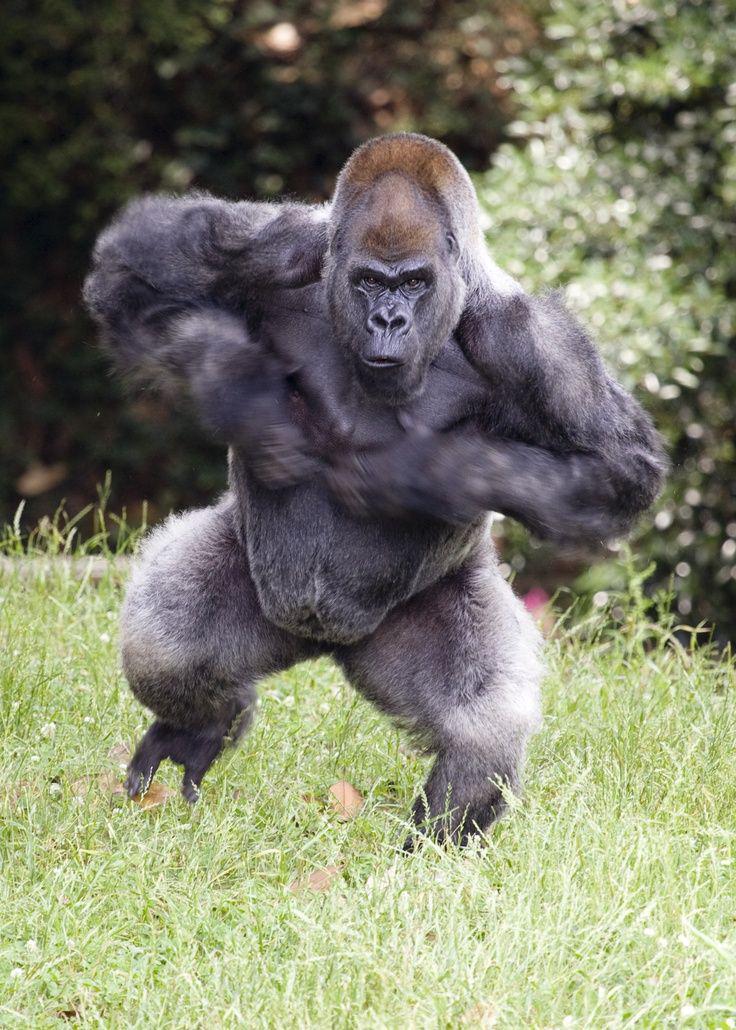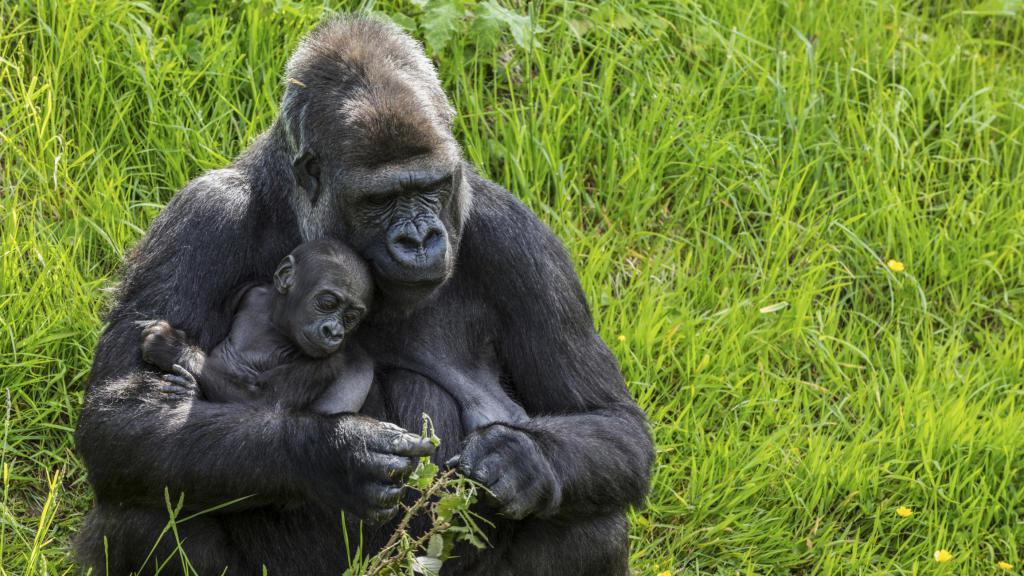The first image is the image on the left, the second image is the image on the right. Assess this claim about the two images: "One of the animals is sitting on the ground.". Correct or not? Answer yes or no. Yes. The first image is the image on the left, the second image is the image on the right. Given the left and right images, does the statement "An image shows a large male gorilla on all fours, with body facing left." hold true? Answer yes or no. No. 